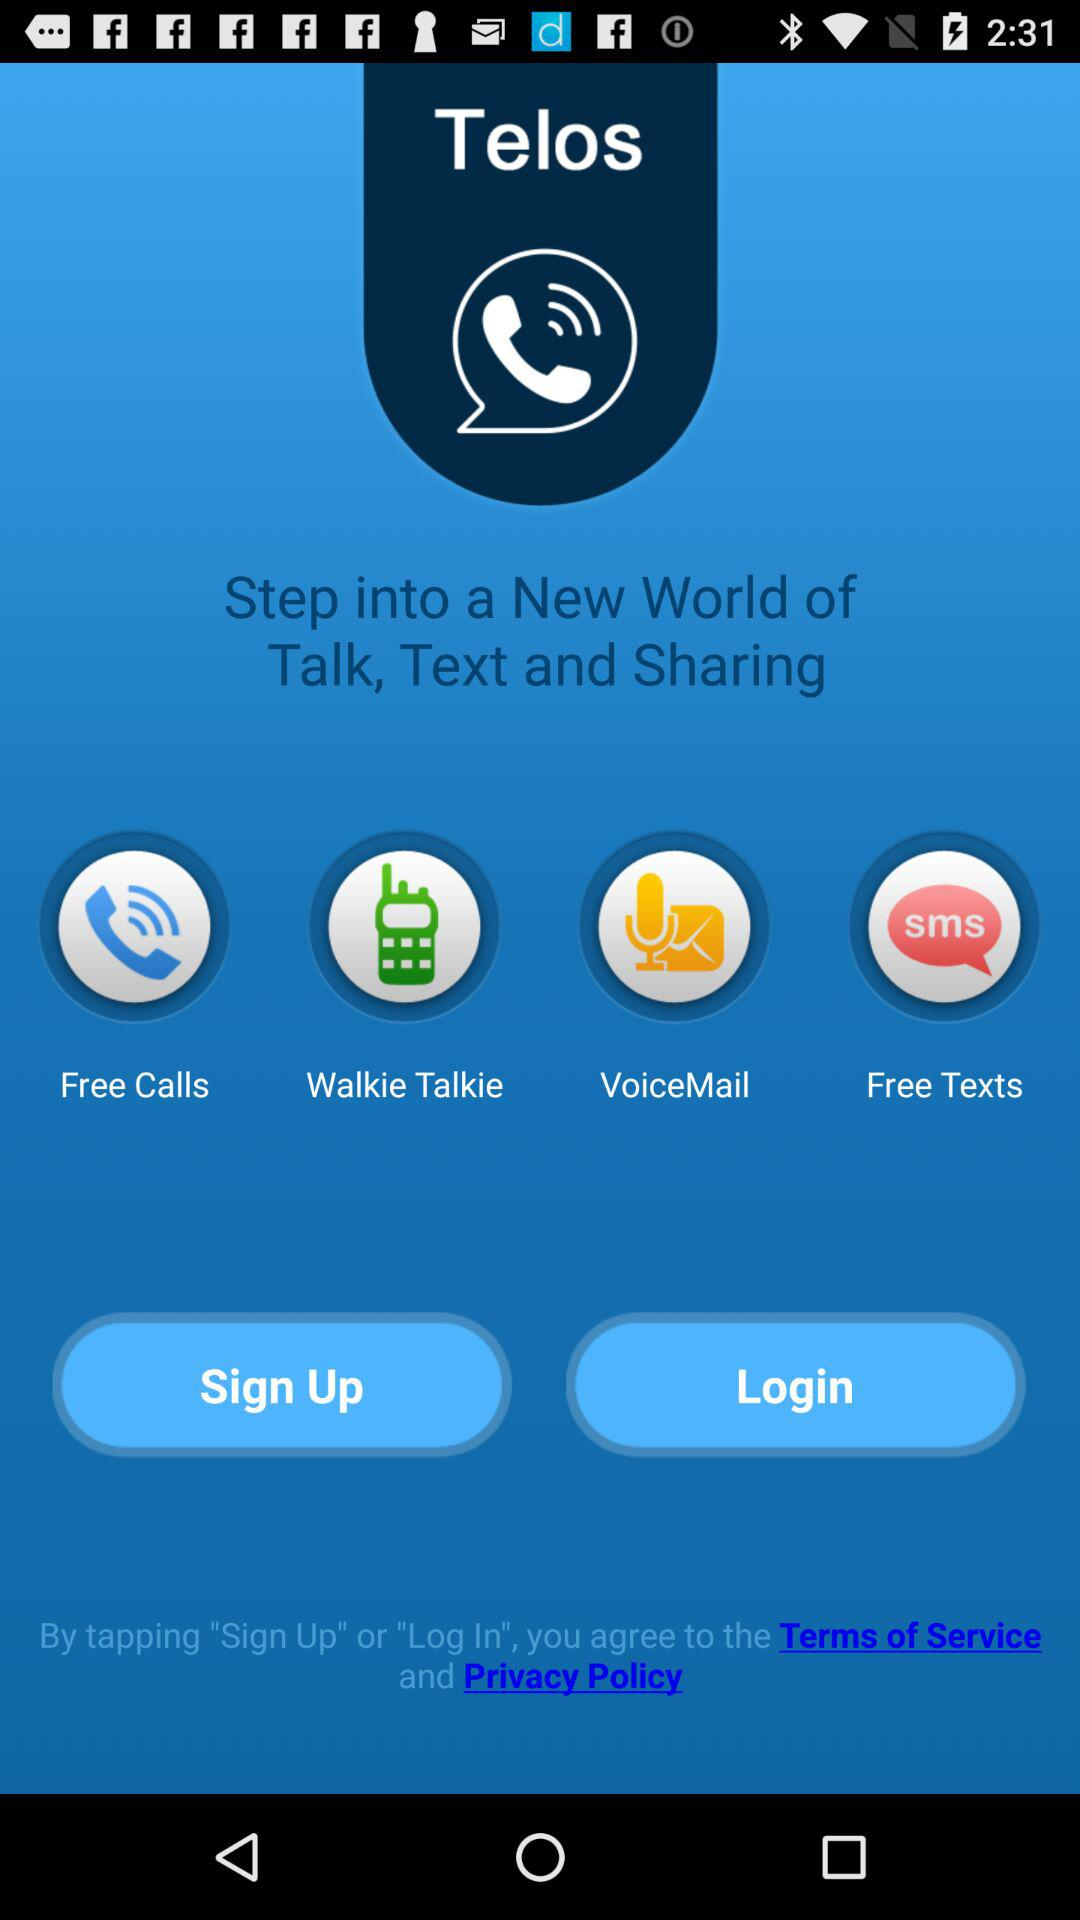What is the name of the application? The name of the application is "Telos". 